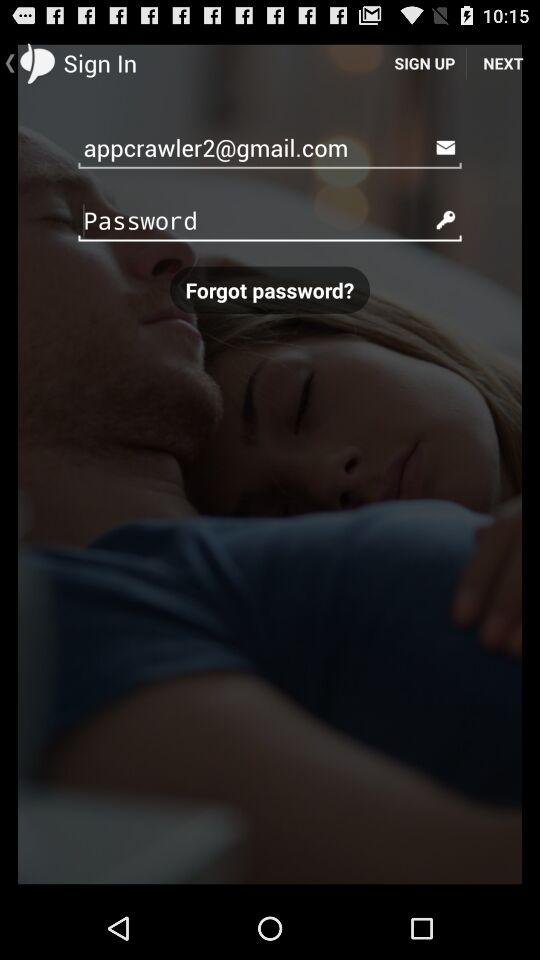How many characters are required to create a password?
When the provided information is insufficient, respond with <no answer>. <no answer> 